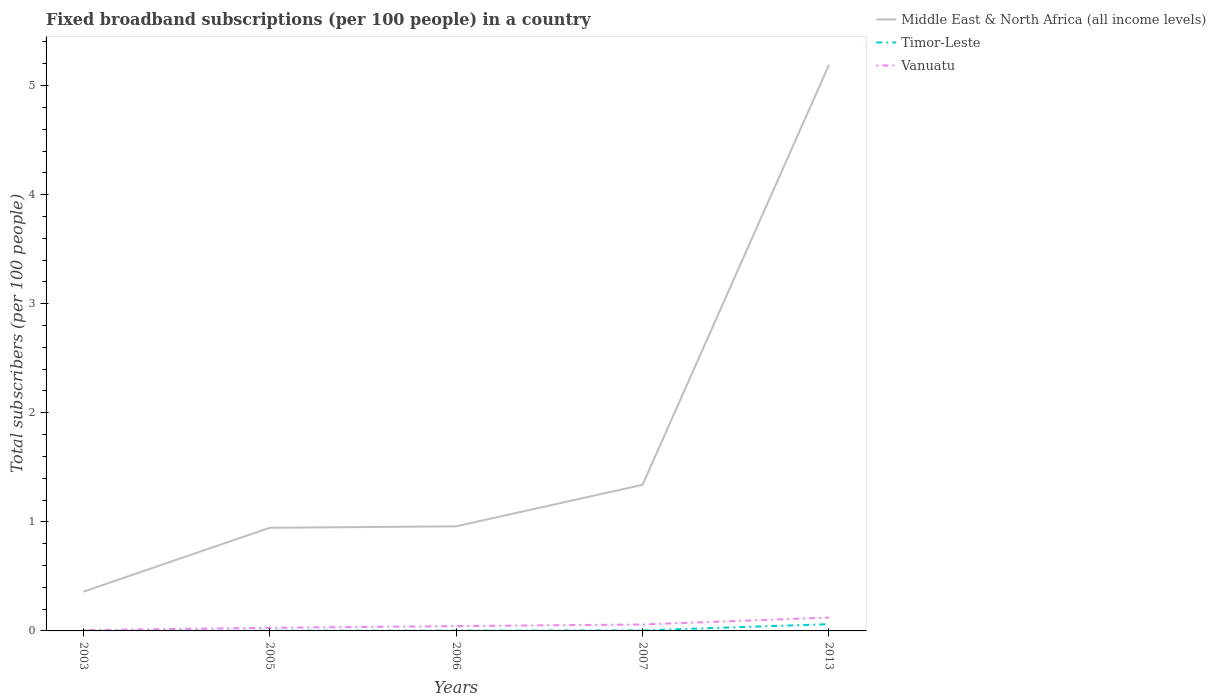How many different coloured lines are there?
Make the answer very short. 3. Does the line corresponding to Timor-Leste intersect with the line corresponding to Middle East & North Africa (all income levels)?
Offer a terse response. No. Across all years, what is the maximum number of broadband subscriptions in Timor-Leste?
Your response must be concise. 0. In which year was the number of broadband subscriptions in Timor-Leste maximum?
Ensure brevity in your answer.  2003. What is the total number of broadband subscriptions in Timor-Leste in the graph?
Your response must be concise. -0.06. What is the difference between the highest and the second highest number of broadband subscriptions in Middle East & North Africa (all income levels)?
Ensure brevity in your answer.  4.83. Is the number of broadband subscriptions in Vanuatu strictly greater than the number of broadband subscriptions in Timor-Leste over the years?
Give a very brief answer. No. How many lines are there?
Your answer should be compact. 3. How many years are there in the graph?
Give a very brief answer. 5. What is the difference between two consecutive major ticks on the Y-axis?
Your answer should be very brief. 1. Are the values on the major ticks of Y-axis written in scientific E-notation?
Give a very brief answer. No. Does the graph contain any zero values?
Offer a terse response. No. Does the graph contain grids?
Your response must be concise. No. Where does the legend appear in the graph?
Your response must be concise. Top right. How are the legend labels stacked?
Keep it short and to the point. Vertical. What is the title of the graph?
Make the answer very short. Fixed broadband subscriptions (per 100 people) in a country. What is the label or title of the X-axis?
Make the answer very short. Years. What is the label or title of the Y-axis?
Ensure brevity in your answer.  Total subscribers (per 100 people). What is the Total subscribers (per 100 people) of Middle East & North Africa (all income levels) in 2003?
Your answer should be compact. 0.36. What is the Total subscribers (per 100 people) in Timor-Leste in 2003?
Your answer should be compact. 0. What is the Total subscribers (per 100 people) in Vanuatu in 2003?
Give a very brief answer. 0.01. What is the Total subscribers (per 100 people) of Middle East & North Africa (all income levels) in 2005?
Make the answer very short. 0.95. What is the Total subscribers (per 100 people) in Timor-Leste in 2005?
Offer a terse response. 0. What is the Total subscribers (per 100 people) of Vanuatu in 2005?
Your answer should be compact. 0.03. What is the Total subscribers (per 100 people) in Middle East & North Africa (all income levels) in 2006?
Offer a terse response. 0.96. What is the Total subscribers (per 100 people) of Timor-Leste in 2006?
Offer a very short reply. 0. What is the Total subscribers (per 100 people) of Vanuatu in 2006?
Give a very brief answer. 0.04. What is the Total subscribers (per 100 people) of Middle East & North Africa (all income levels) in 2007?
Make the answer very short. 1.34. What is the Total subscribers (per 100 people) in Timor-Leste in 2007?
Offer a terse response. 0. What is the Total subscribers (per 100 people) in Vanuatu in 2007?
Offer a very short reply. 0.06. What is the Total subscribers (per 100 people) of Middle East & North Africa (all income levels) in 2013?
Your answer should be very brief. 5.19. What is the Total subscribers (per 100 people) in Timor-Leste in 2013?
Offer a terse response. 0.06. What is the Total subscribers (per 100 people) in Vanuatu in 2013?
Offer a terse response. 0.12. Across all years, what is the maximum Total subscribers (per 100 people) of Middle East & North Africa (all income levels)?
Offer a very short reply. 5.19. Across all years, what is the maximum Total subscribers (per 100 people) in Timor-Leste?
Give a very brief answer. 0.06. Across all years, what is the maximum Total subscribers (per 100 people) of Vanuatu?
Offer a terse response. 0.12. Across all years, what is the minimum Total subscribers (per 100 people) of Middle East & North Africa (all income levels)?
Offer a very short reply. 0.36. Across all years, what is the minimum Total subscribers (per 100 people) in Timor-Leste?
Ensure brevity in your answer.  0. Across all years, what is the minimum Total subscribers (per 100 people) of Vanuatu?
Ensure brevity in your answer.  0.01. What is the total Total subscribers (per 100 people) in Middle East & North Africa (all income levels) in the graph?
Make the answer very short. 8.79. What is the total Total subscribers (per 100 people) of Timor-Leste in the graph?
Keep it short and to the point. 0.07. What is the total Total subscribers (per 100 people) of Vanuatu in the graph?
Provide a succinct answer. 0.26. What is the difference between the Total subscribers (per 100 people) of Middle East & North Africa (all income levels) in 2003 and that in 2005?
Give a very brief answer. -0.59. What is the difference between the Total subscribers (per 100 people) of Timor-Leste in 2003 and that in 2005?
Provide a succinct answer. -0. What is the difference between the Total subscribers (per 100 people) in Vanuatu in 2003 and that in 2005?
Give a very brief answer. -0.02. What is the difference between the Total subscribers (per 100 people) in Middle East & North Africa (all income levels) in 2003 and that in 2006?
Your answer should be very brief. -0.6. What is the difference between the Total subscribers (per 100 people) of Timor-Leste in 2003 and that in 2006?
Provide a short and direct response. -0. What is the difference between the Total subscribers (per 100 people) of Vanuatu in 2003 and that in 2006?
Keep it short and to the point. -0.04. What is the difference between the Total subscribers (per 100 people) of Middle East & North Africa (all income levels) in 2003 and that in 2007?
Your answer should be very brief. -0.98. What is the difference between the Total subscribers (per 100 people) of Timor-Leste in 2003 and that in 2007?
Offer a terse response. -0. What is the difference between the Total subscribers (per 100 people) in Vanuatu in 2003 and that in 2007?
Give a very brief answer. -0.05. What is the difference between the Total subscribers (per 100 people) in Middle East & North Africa (all income levels) in 2003 and that in 2013?
Your answer should be compact. -4.83. What is the difference between the Total subscribers (per 100 people) of Timor-Leste in 2003 and that in 2013?
Give a very brief answer. -0.06. What is the difference between the Total subscribers (per 100 people) in Vanuatu in 2003 and that in 2013?
Your answer should be compact. -0.12. What is the difference between the Total subscribers (per 100 people) in Middle East & North Africa (all income levels) in 2005 and that in 2006?
Your answer should be compact. -0.01. What is the difference between the Total subscribers (per 100 people) of Timor-Leste in 2005 and that in 2006?
Your response must be concise. -0. What is the difference between the Total subscribers (per 100 people) in Vanuatu in 2005 and that in 2006?
Your answer should be very brief. -0.02. What is the difference between the Total subscribers (per 100 people) of Middle East & North Africa (all income levels) in 2005 and that in 2007?
Keep it short and to the point. -0.39. What is the difference between the Total subscribers (per 100 people) in Timor-Leste in 2005 and that in 2007?
Your answer should be compact. -0. What is the difference between the Total subscribers (per 100 people) of Vanuatu in 2005 and that in 2007?
Provide a short and direct response. -0.03. What is the difference between the Total subscribers (per 100 people) of Middle East & North Africa (all income levels) in 2005 and that in 2013?
Provide a succinct answer. -4.24. What is the difference between the Total subscribers (per 100 people) of Timor-Leste in 2005 and that in 2013?
Give a very brief answer. -0.06. What is the difference between the Total subscribers (per 100 people) of Vanuatu in 2005 and that in 2013?
Your answer should be very brief. -0.09. What is the difference between the Total subscribers (per 100 people) of Middle East & North Africa (all income levels) in 2006 and that in 2007?
Ensure brevity in your answer.  -0.38. What is the difference between the Total subscribers (per 100 people) of Timor-Leste in 2006 and that in 2007?
Keep it short and to the point. -0. What is the difference between the Total subscribers (per 100 people) of Vanuatu in 2006 and that in 2007?
Keep it short and to the point. -0.01. What is the difference between the Total subscribers (per 100 people) of Middle East & North Africa (all income levels) in 2006 and that in 2013?
Make the answer very short. -4.23. What is the difference between the Total subscribers (per 100 people) of Timor-Leste in 2006 and that in 2013?
Offer a terse response. -0.06. What is the difference between the Total subscribers (per 100 people) in Vanuatu in 2006 and that in 2013?
Keep it short and to the point. -0.08. What is the difference between the Total subscribers (per 100 people) in Middle East & North Africa (all income levels) in 2007 and that in 2013?
Give a very brief answer. -3.85. What is the difference between the Total subscribers (per 100 people) of Timor-Leste in 2007 and that in 2013?
Provide a succinct answer. -0.06. What is the difference between the Total subscribers (per 100 people) of Vanuatu in 2007 and that in 2013?
Your answer should be very brief. -0.06. What is the difference between the Total subscribers (per 100 people) in Middle East & North Africa (all income levels) in 2003 and the Total subscribers (per 100 people) in Timor-Leste in 2005?
Your answer should be compact. 0.36. What is the difference between the Total subscribers (per 100 people) of Middle East & North Africa (all income levels) in 2003 and the Total subscribers (per 100 people) of Vanuatu in 2005?
Your response must be concise. 0.33. What is the difference between the Total subscribers (per 100 people) of Timor-Leste in 2003 and the Total subscribers (per 100 people) of Vanuatu in 2005?
Keep it short and to the point. -0.03. What is the difference between the Total subscribers (per 100 people) in Middle East & North Africa (all income levels) in 2003 and the Total subscribers (per 100 people) in Timor-Leste in 2006?
Give a very brief answer. 0.36. What is the difference between the Total subscribers (per 100 people) in Middle East & North Africa (all income levels) in 2003 and the Total subscribers (per 100 people) in Vanuatu in 2006?
Provide a succinct answer. 0.32. What is the difference between the Total subscribers (per 100 people) of Timor-Leste in 2003 and the Total subscribers (per 100 people) of Vanuatu in 2006?
Make the answer very short. -0.04. What is the difference between the Total subscribers (per 100 people) in Middle East & North Africa (all income levels) in 2003 and the Total subscribers (per 100 people) in Timor-Leste in 2007?
Your answer should be very brief. 0.35. What is the difference between the Total subscribers (per 100 people) in Middle East & North Africa (all income levels) in 2003 and the Total subscribers (per 100 people) in Vanuatu in 2007?
Provide a short and direct response. 0.3. What is the difference between the Total subscribers (per 100 people) of Timor-Leste in 2003 and the Total subscribers (per 100 people) of Vanuatu in 2007?
Give a very brief answer. -0.06. What is the difference between the Total subscribers (per 100 people) in Middle East & North Africa (all income levels) in 2003 and the Total subscribers (per 100 people) in Timor-Leste in 2013?
Make the answer very short. 0.3. What is the difference between the Total subscribers (per 100 people) in Middle East & North Africa (all income levels) in 2003 and the Total subscribers (per 100 people) in Vanuatu in 2013?
Give a very brief answer. 0.24. What is the difference between the Total subscribers (per 100 people) in Timor-Leste in 2003 and the Total subscribers (per 100 people) in Vanuatu in 2013?
Keep it short and to the point. -0.12. What is the difference between the Total subscribers (per 100 people) in Middle East & North Africa (all income levels) in 2005 and the Total subscribers (per 100 people) in Timor-Leste in 2006?
Give a very brief answer. 0.94. What is the difference between the Total subscribers (per 100 people) in Middle East & North Africa (all income levels) in 2005 and the Total subscribers (per 100 people) in Vanuatu in 2006?
Make the answer very short. 0.9. What is the difference between the Total subscribers (per 100 people) in Timor-Leste in 2005 and the Total subscribers (per 100 people) in Vanuatu in 2006?
Offer a very short reply. -0.04. What is the difference between the Total subscribers (per 100 people) in Middle East & North Africa (all income levels) in 2005 and the Total subscribers (per 100 people) in Timor-Leste in 2007?
Your response must be concise. 0.94. What is the difference between the Total subscribers (per 100 people) of Middle East & North Africa (all income levels) in 2005 and the Total subscribers (per 100 people) of Vanuatu in 2007?
Give a very brief answer. 0.89. What is the difference between the Total subscribers (per 100 people) in Timor-Leste in 2005 and the Total subscribers (per 100 people) in Vanuatu in 2007?
Provide a succinct answer. -0.06. What is the difference between the Total subscribers (per 100 people) in Middle East & North Africa (all income levels) in 2005 and the Total subscribers (per 100 people) in Timor-Leste in 2013?
Your response must be concise. 0.88. What is the difference between the Total subscribers (per 100 people) of Middle East & North Africa (all income levels) in 2005 and the Total subscribers (per 100 people) of Vanuatu in 2013?
Offer a terse response. 0.82. What is the difference between the Total subscribers (per 100 people) of Timor-Leste in 2005 and the Total subscribers (per 100 people) of Vanuatu in 2013?
Keep it short and to the point. -0.12. What is the difference between the Total subscribers (per 100 people) of Middle East & North Africa (all income levels) in 2006 and the Total subscribers (per 100 people) of Timor-Leste in 2007?
Offer a terse response. 0.95. What is the difference between the Total subscribers (per 100 people) of Middle East & North Africa (all income levels) in 2006 and the Total subscribers (per 100 people) of Vanuatu in 2007?
Your answer should be compact. 0.9. What is the difference between the Total subscribers (per 100 people) in Timor-Leste in 2006 and the Total subscribers (per 100 people) in Vanuatu in 2007?
Ensure brevity in your answer.  -0.06. What is the difference between the Total subscribers (per 100 people) of Middle East & North Africa (all income levels) in 2006 and the Total subscribers (per 100 people) of Timor-Leste in 2013?
Provide a succinct answer. 0.9. What is the difference between the Total subscribers (per 100 people) of Middle East & North Africa (all income levels) in 2006 and the Total subscribers (per 100 people) of Vanuatu in 2013?
Your answer should be compact. 0.84. What is the difference between the Total subscribers (per 100 people) of Timor-Leste in 2006 and the Total subscribers (per 100 people) of Vanuatu in 2013?
Offer a very short reply. -0.12. What is the difference between the Total subscribers (per 100 people) in Middle East & North Africa (all income levels) in 2007 and the Total subscribers (per 100 people) in Timor-Leste in 2013?
Your answer should be very brief. 1.28. What is the difference between the Total subscribers (per 100 people) of Middle East & North Africa (all income levels) in 2007 and the Total subscribers (per 100 people) of Vanuatu in 2013?
Give a very brief answer. 1.22. What is the difference between the Total subscribers (per 100 people) of Timor-Leste in 2007 and the Total subscribers (per 100 people) of Vanuatu in 2013?
Make the answer very short. -0.12. What is the average Total subscribers (per 100 people) in Middle East & North Africa (all income levels) per year?
Offer a terse response. 1.76. What is the average Total subscribers (per 100 people) of Timor-Leste per year?
Give a very brief answer. 0.01. What is the average Total subscribers (per 100 people) of Vanuatu per year?
Your response must be concise. 0.05. In the year 2003, what is the difference between the Total subscribers (per 100 people) of Middle East & North Africa (all income levels) and Total subscribers (per 100 people) of Timor-Leste?
Your answer should be compact. 0.36. In the year 2003, what is the difference between the Total subscribers (per 100 people) of Middle East & North Africa (all income levels) and Total subscribers (per 100 people) of Vanuatu?
Give a very brief answer. 0.35. In the year 2003, what is the difference between the Total subscribers (per 100 people) in Timor-Leste and Total subscribers (per 100 people) in Vanuatu?
Make the answer very short. -0.01. In the year 2005, what is the difference between the Total subscribers (per 100 people) of Middle East & North Africa (all income levels) and Total subscribers (per 100 people) of Timor-Leste?
Keep it short and to the point. 0.94. In the year 2005, what is the difference between the Total subscribers (per 100 people) of Middle East & North Africa (all income levels) and Total subscribers (per 100 people) of Vanuatu?
Provide a succinct answer. 0.92. In the year 2005, what is the difference between the Total subscribers (per 100 people) of Timor-Leste and Total subscribers (per 100 people) of Vanuatu?
Give a very brief answer. -0.03. In the year 2006, what is the difference between the Total subscribers (per 100 people) of Middle East & North Africa (all income levels) and Total subscribers (per 100 people) of Timor-Leste?
Ensure brevity in your answer.  0.96. In the year 2006, what is the difference between the Total subscribers (per 100 people) of Middle East & North Africa (all income levels) and Total subscribers (per 100 people) of Vanuatu?
Ensure brevity in your answer.  0.91. In the year 2006, what is the difference between the Total subscribers (per 100 people) of Timor-Leste and Total subscribers (per 100 people) of Vanuatu?
Provide a short and direct response. -0.04. In the year 2007, what is the difference between the Total subscribers (per 100 people) of Middle East & North Africa (all income levels) and Total subscribers (per 100 people) of Timor-Leste?
Provide a succinct answer. 1.34. In the year 2007, what is the difference between the Total subscribers (per 100 people) of Middle East & North Africa (all income levels) and Total subscribers (per 100 people) of Vanuatu?
Offer a very short reply. 1.28. In the year 2007, what is the difference between the Total subscribers (per 100 people) of Timor-Leste and Total subscribers (per 100 people) of Vanuatu?
Provide a short and direct response. -0.05. In the year 2013, what is the difference between the Total subscribers (per 100 people) of Middle East & North Africa (all income levels) and Total subscribers (per 100 people) of Timor-Leste?
Provide a succinct answer. 5.13. In the year 2013, what is the difference between the Total subscribers (per 100 people) of Middle East & North Africa (all income levels) and Total subscribers (per 100 people) of Vanuatu?
Offer a very short reply. 5.07. In the year 2013, what is the difference between the Total subscribers (per 100 people) in Timor-Leste and Total subscribers (per 100 people) in Vanuatu?
Your answer should be very brief. -0.06. What is the ratio of the Total subscribers (per 100 people) in Middle East & North Africa (all income levels) in 2003 to that in 2005?
Your response must be concise. 0.38. What is the ratio of the Total subscribers (per 100 people) in Timor-Leste in 2003 to that in 2005?
Make the answer very short. 0.44. What is the ratio of the Total subscribers (per 100 people) in Vanuatu in 2003 to that in 2005?
Offer a very short reply. 0.27. What is the ratio of the Total subscribers (per 100 people) in Middle East & North Africa (all income levels) in 2003 to that in 2006?
Provide a succinct answer. 0.37. What is the ratio of the Total subscribers (per 100 people) in Timor-Leste in 2003 to that in 2006?
Give a very brief answer. 0.34. What is the ratio of the Total subscribers (per 100 people) in Vanuatu in 2003 to that in 2006?
Provide a short and direct response. 0.17. What is the ratio of the Total subscribers (per 100 people) of Middle East & North Africa (all income levels) in 2003 to that in 2007?
Provide a succinct answer. 0.27. What is the ratio of the Total subscribers (per 100 people) in Timor-Leste in 2003 to that in 2007?
Your answer should be very brief. 0.2. What is the ratio of the Total subscribers (per 100 people) of Vanuatu in 2003 to that in 2007?
Give a very brief answer. 0.13. What is the ratio of the Total subscribers (per 100 people) of Middle East & North Africa (all income levels) in 2003 to that in 2013?
Your answer should be compact. 0.07. What is the ratio of the Total subscribers (per 100 people) of Timor-Leste in 2003 to that in 2013?
Ensure brevity in your answer.  0.02. What is the ratio of the Total subscribers (per 100 people) of Vanuatu in 2003 to that in 2013?
Your answer should be compact. 0.06. What is the ratio of the Total subscribers (per 100 people) of Middle East & North Africa (all income levels) in 2005 to that in 2006?
Offer a terse response. 0.99. What is the ratio of the Total subscribers (per 100 people) in Timor-Leste in 2005 to that in 2006?
Provide a short and direct response. 0.78. What is the ratio of the Total subscribers (per 100 people) in Vanuatu in 2005 to that in 2006?
Your answer should be very brief. 0.64. What is the ratio of the Total subscribers (per 100 people) of Middle East & North Africa (all income levels) in 2005 to that in 2007?
Give a very brief answer. 0.71. What is the ratio of the Total subscribers (per 100 people) of Timor-Leste in 2005 to that in 2007?
Your answer should be very brief. 0.46. What is the ratio of the Total subscribers (per 100 people) in Vanuatu in 2005 to that in 2007?
Ensure brevity in your answer.  0.48. What is the ratio of the Total subscribers (per 100 people) of Middle East & North Africa (all income levels) in 2005 to that in 2013?
Provide a short and direct response. 0.18. What is the ratio of the Total subscribers (per 100 people) in Timor-Leste in 2005 to that in 2013?
Give a very brief answer. 0.04. What is the ratio of the Total subscribers (per 100 people) of Vanuatu in 2005 to that in 2013?
Make the answer very short. 0.23. What is the ratio of the Total subscribers (per 100 people) in Middle East & North Africa (all income levels) in 2006 to that in 2007?
Keep it short and to the point. 0.72. What is the ratio of the Total subscribers (per 100 people) in Timor-Leste in 2006 to that in 2007?
Your response must be concise. 0.59. What is the ratio of the Total subscribers (per 100 people) in Vanuatu in 2006 to that in 2007?
Give a very brief answer. 0.75. What is the ratio of the Total subscribers (per 100 people) in Middle East & North Africa (all income levels) in 2006 to that in 2013?
Offer a terse response. 0.18. What is the ratio of the Total subscribers (per 100 people) in Timor-Leste in 2006 to that in 2013?
Provide a short and direct response. 0.05. What is the ratio of the Total subscribers (per 100 people) in Vanuatu in 2006 to that in 2013?
Provide a succinct answer. 0.36. What is the ratio of the Total subscribers (per 100 people) in Middle East & North Africa (all income levels) in 2007 to that in 2013?
Provide a short and direct response. 0.26. What is the ratio of the Total subscribers (per 100 people) of Timor-Leste in 2007 to that in 2013?
Your answer should be very brief. 0.08. What is the ratio of the Total subscribers (per 100 people) in Vanuatu in 2007 to that in 2013?
Make the answer very short. 0.48. What is the difference between the highest and the second highest Total subscribers (per 100 people) of Middle East & North Africa (all income levels)?
Offer a terse response. 3.85. What is the difference between the highest and the second highest Total subscribers (per 100 people) in Timor-Leste?
Offer a terse response. 0.06. What is the difference between the highest and the second highest Total subscribers (per 100 people) in Vanuatu?
Provide a succinct answer. 0.06. What is the difference between the highest and the lowest Total subscribers (per 100 people) of Middle East & North Africa (all income levels)?
Your answer should be compact. 4.83. What is the difference between the highest and the lowest Total subscribers (per 100 people) of Timor-Leste?
Keep it short and to the point. 0.06. What is the difference between the highest and the lowest Total subscribers (per 100 people) of Vanuatu?
Your answer should be compact. 0.12. 